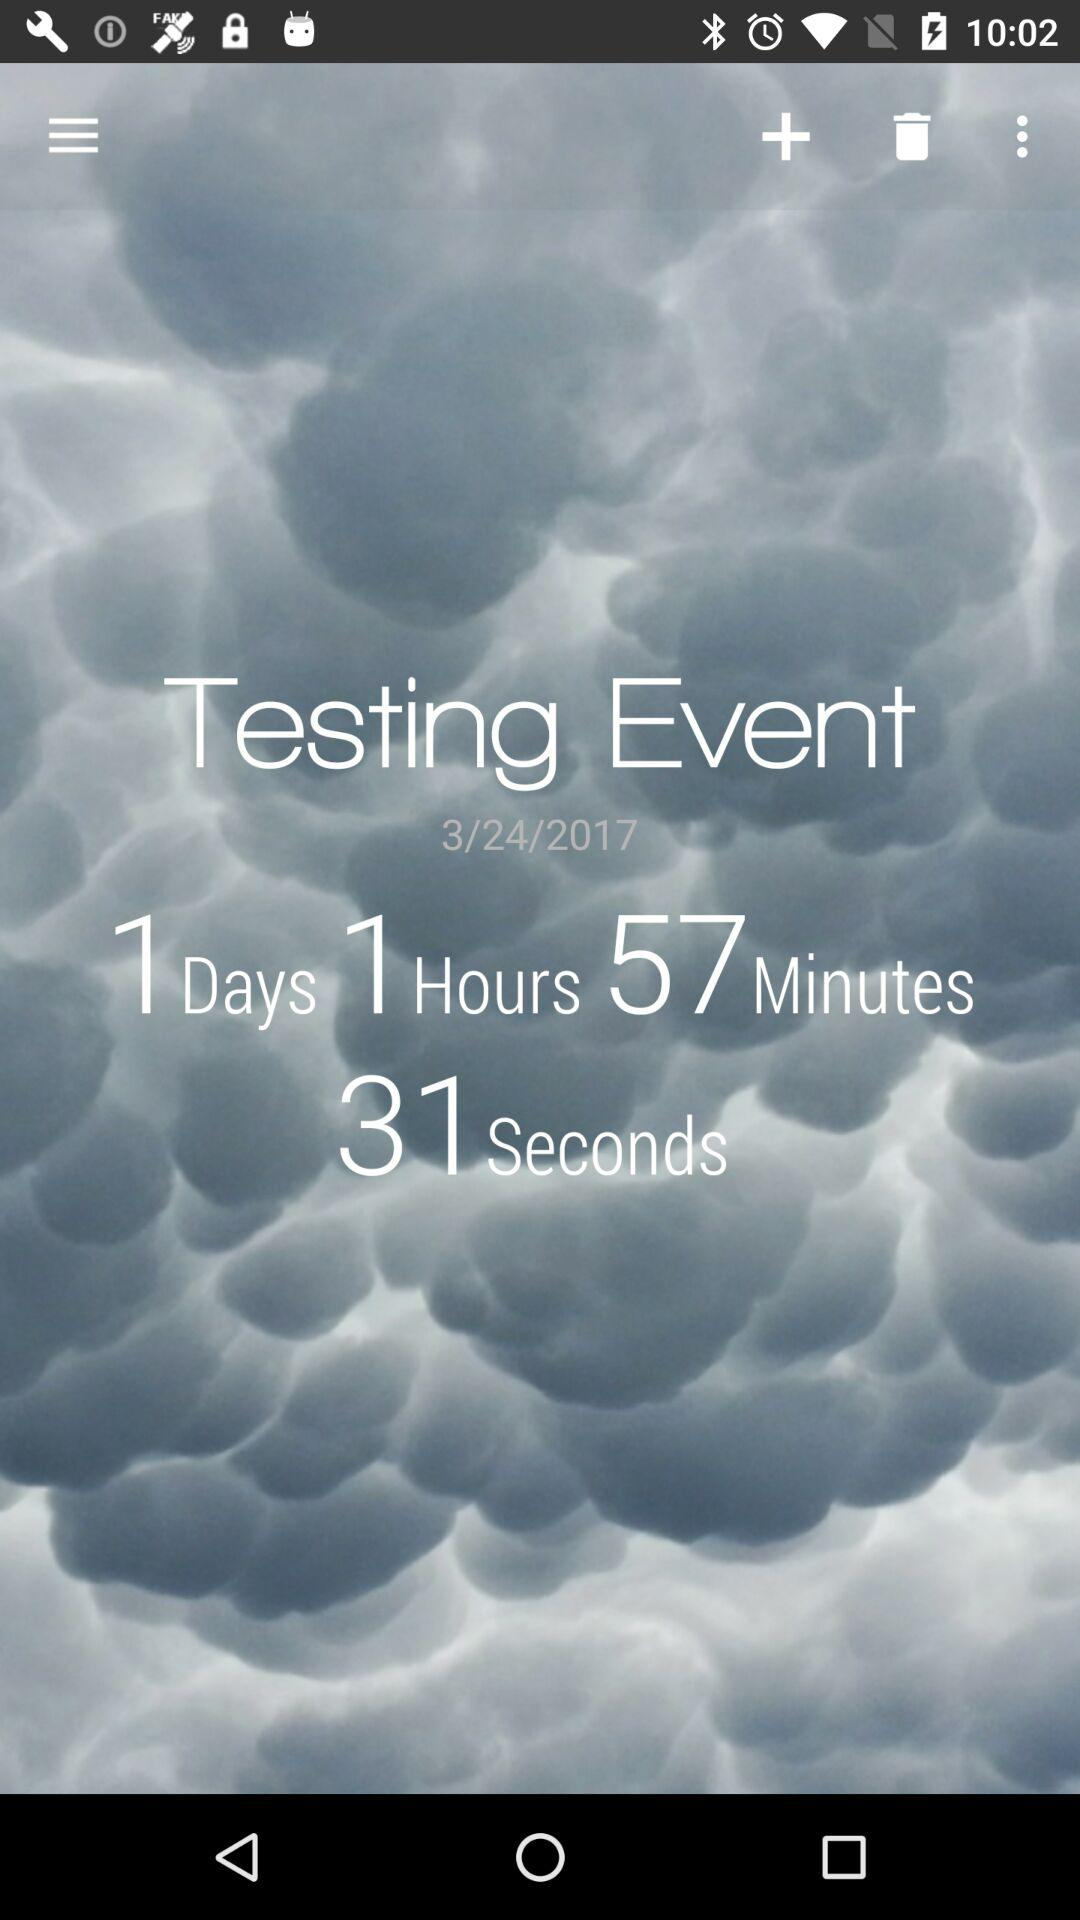What is the date of the event? The date of the event is March 24, 2017. 